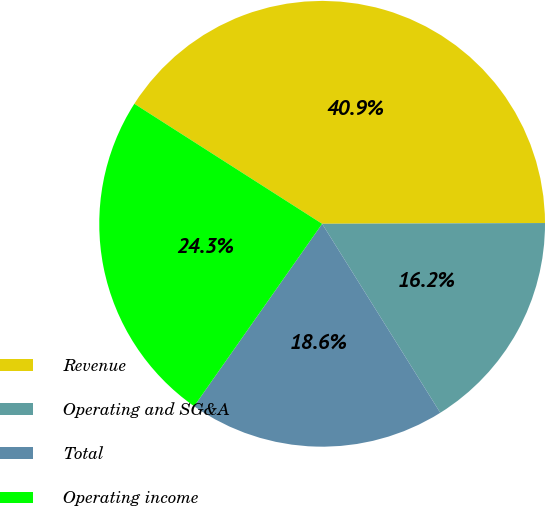<chart> <loc_0><loc_0><loc_500><loc_500><pie_chart><fcel>Revenue<fcel>Operating and SG&A<fcel>Total<fcel>Operating income<nl><fcel>40.89%<fcel>16.16%<fcel>18.63%<fcel>24.31%<nl></chart> 